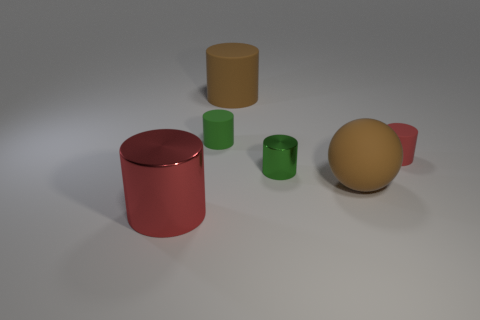How many other objects are the same material as the big red cylinder?
Ensure brevity in your answer.  1. What number of red things are either rubber spheres or tiny cylinders?
Give a very brief answer. 1. There is a brown rubber thing that is behind the small green rubber thing; is it the same shape as the brown rubber object that is in front of the green rubber cylinder?
Offer a very short reply. No. There is a matte ball; is it the same color as the tiny thing on the left side of the tiny green metallic thing?
Your response must be concise. No. There is a large rubber object behind the large sphere; is its color the same as the ball?
Your answer should be very brief. Yes. What number of objects are either small green metallic cylinders or big rubber things behind the small green rubber object?
Ensure brevity in your answer.  2. What material is the big thing that is to the left of the large brown sphere and behind the big red cylinder?
Offer a very short reply. Rubber. What is the material of the red thing that is to the left of the green metallic cylinder?
Provide a short and direct response. Metal. The cylinder that is the same material as the large red thing is what color?
Provide a short and direct response. Green. Does the small green matte object have the same shape as the metal object that is behind the big red object?
Keep it short and to the point. Yes. 